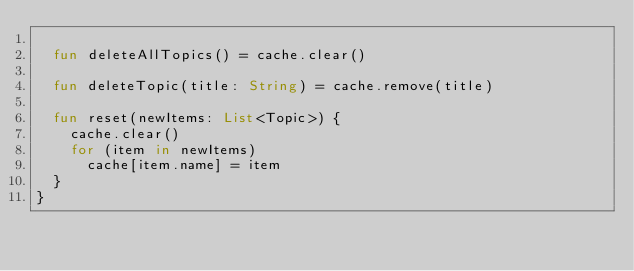Convert code to text. <code><loc_0><loc_0><loc_500><loc_500><_Kotlin_>
	fun deleteAllTopics() = cache.clear()

	fun deleteTopic(title: String) = cache.remove(title)

	fun reset(newItems: List<Topic>) {
		cache.clear()
		for (item in newItems)
			cache[item.name] = item
	}
}</code> 